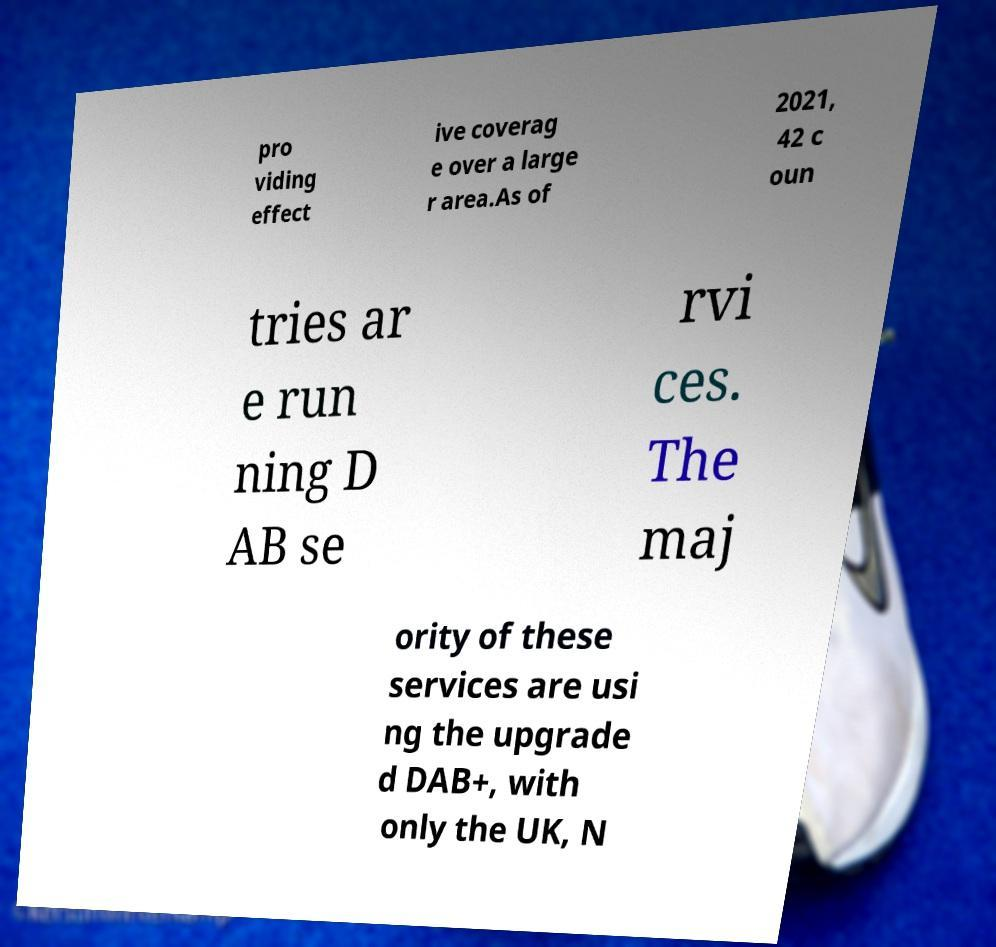Can you accurately transcribe the text from the provided image for me? pro viding effect ive coverag e over a large r area.As of 2021, 42 c oun tries ar e run ning D AB se rvi ces. The maj ority of these services are usi ng the upgrade d DAB+, with only the UK, N 